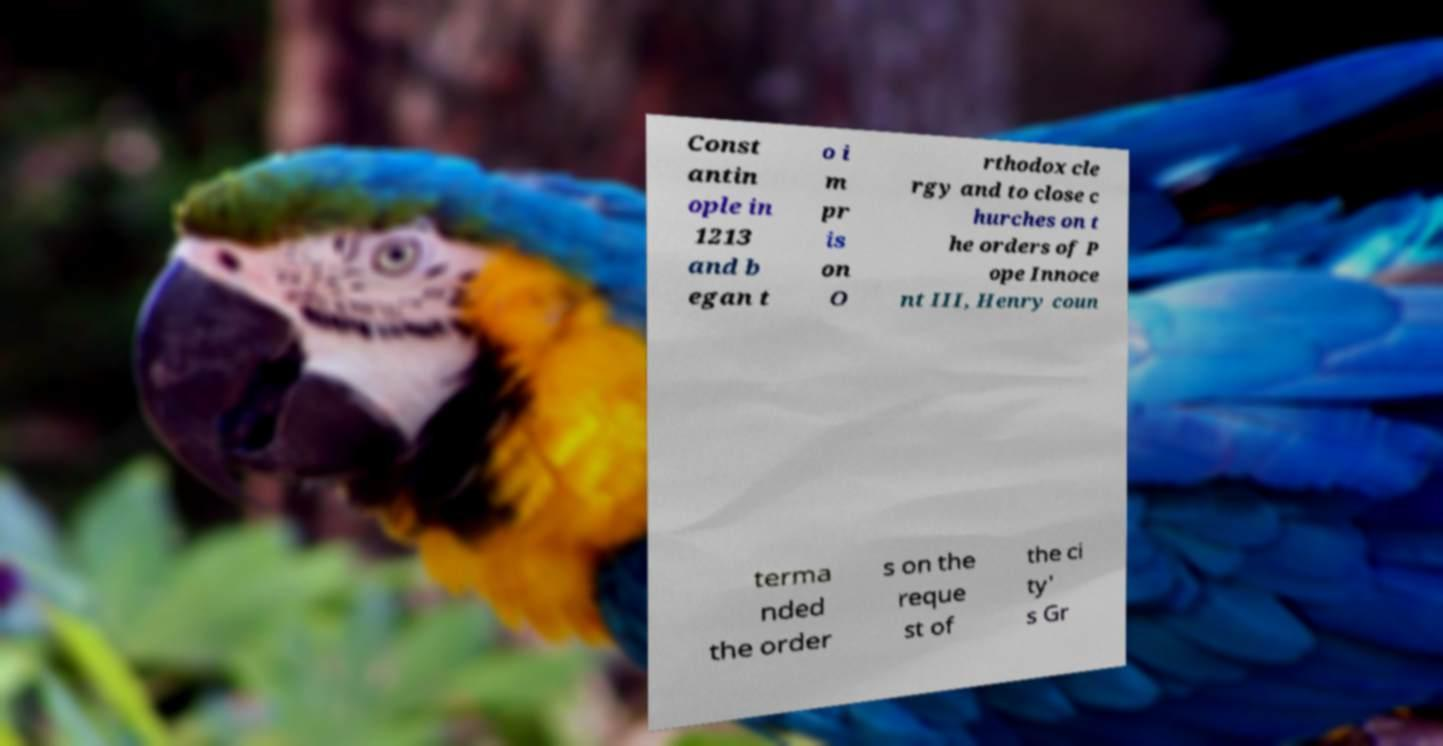For documentation purposes, I need the text within this image transcribed. Could you provide that? Const antin ople in 1213 and b egan t o i m pr is on O rthodox cle rgy and to close c hurches on t he orders of P ope Innoce nt III, Henry coun terma nded the order s on the reque st of the ci ty' s Gr 